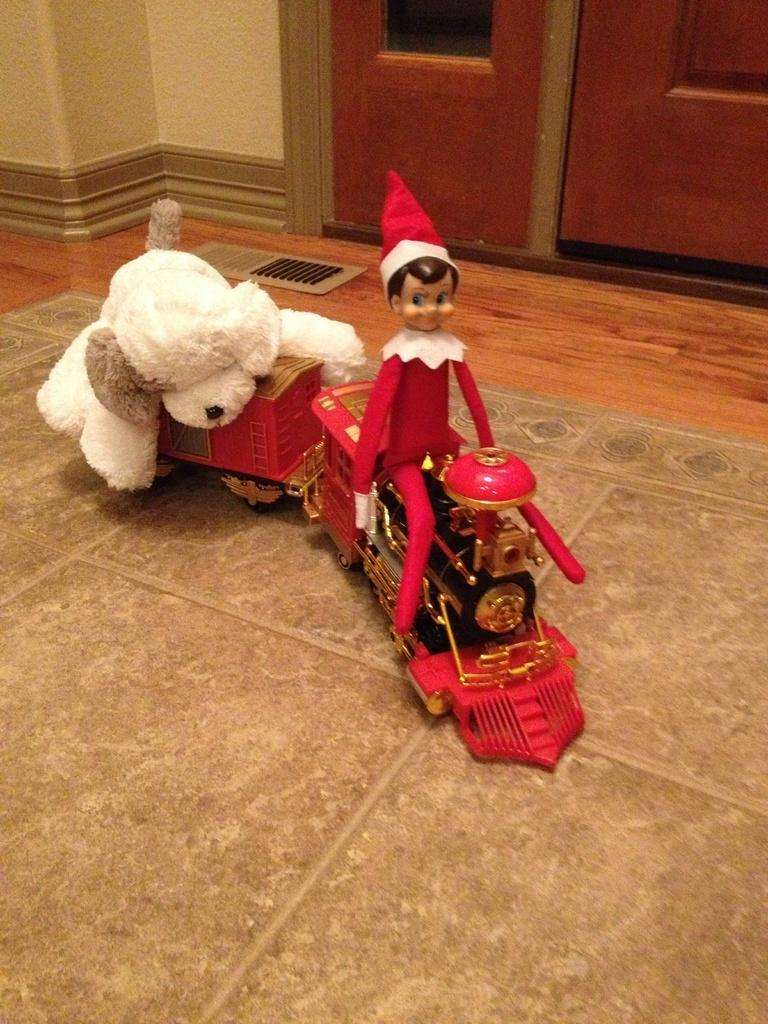What type of objects can be seen in the image? There are toys in the image. Can you identify a specific toy in the image? Yes, there is a teddy bear in the image. What type of architectural features are present in the image? There is a door and a wall in the image. What flavor of news can be found on the page in the image? There is no page or news present in the image; it features toys, a teddy bear, a door, and a wall. 